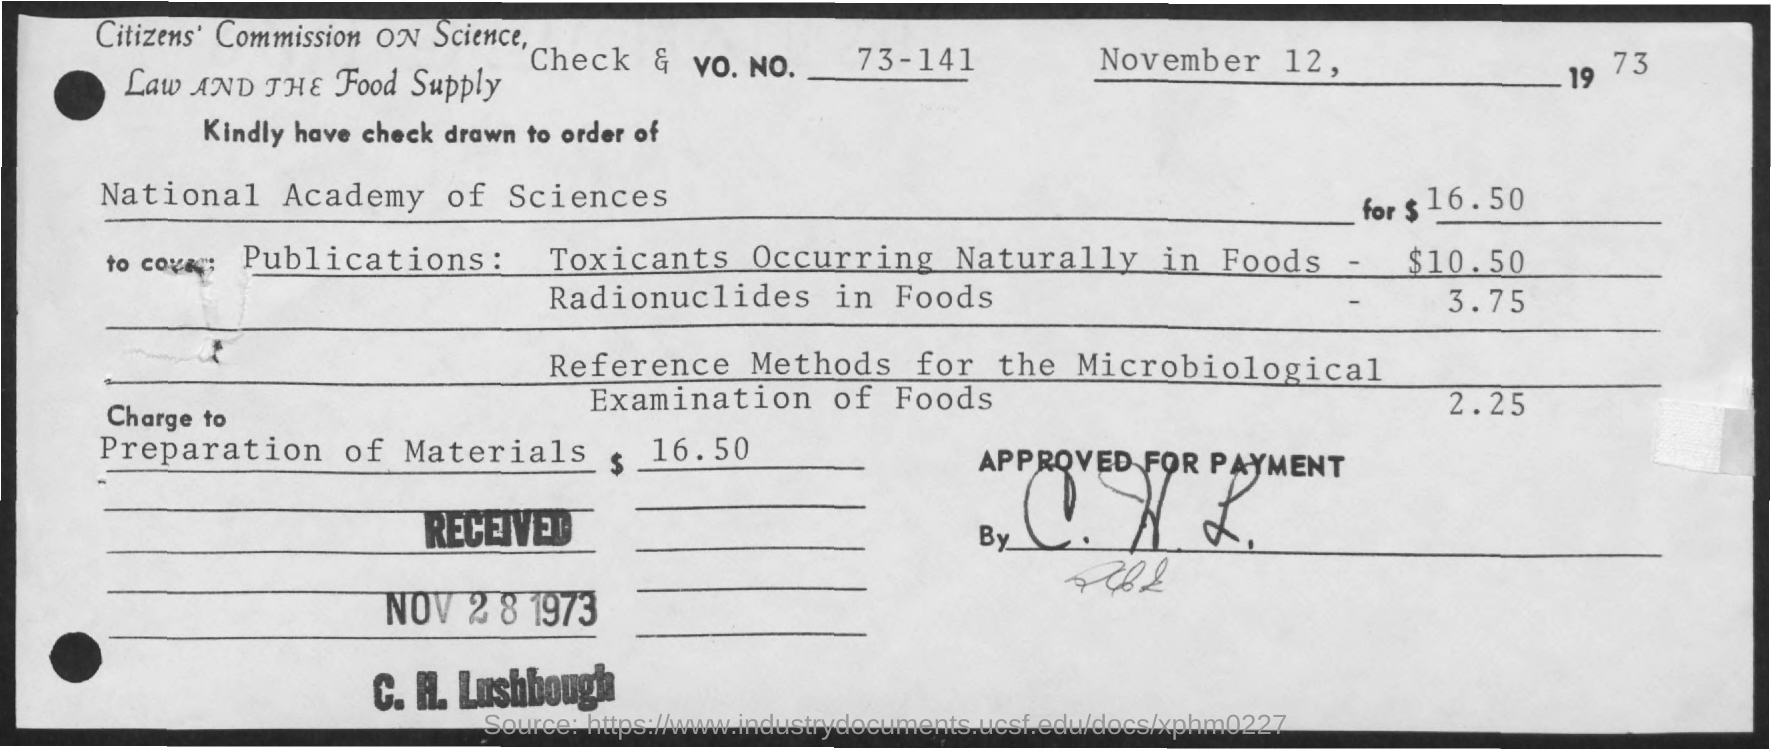What is the date mentioned in the given page ?
Keep it short and to the point. November 12, 1973. What is the received date mentioned ?
Your answer should be compact. NOV 28 1973. What is the amount mentioned for preparation of materials ?
Ensure brevity in your answer.  $ 16.50. What is the name of check drawn to order of as mentioned in the given check?
Provide a short and direct response. National academy of sciences. 